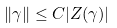<formula> <loc_0><loc_0><loc_500><loc_500>\| \gamma \| \leq C | Z ( \gamma ) |</formula> 